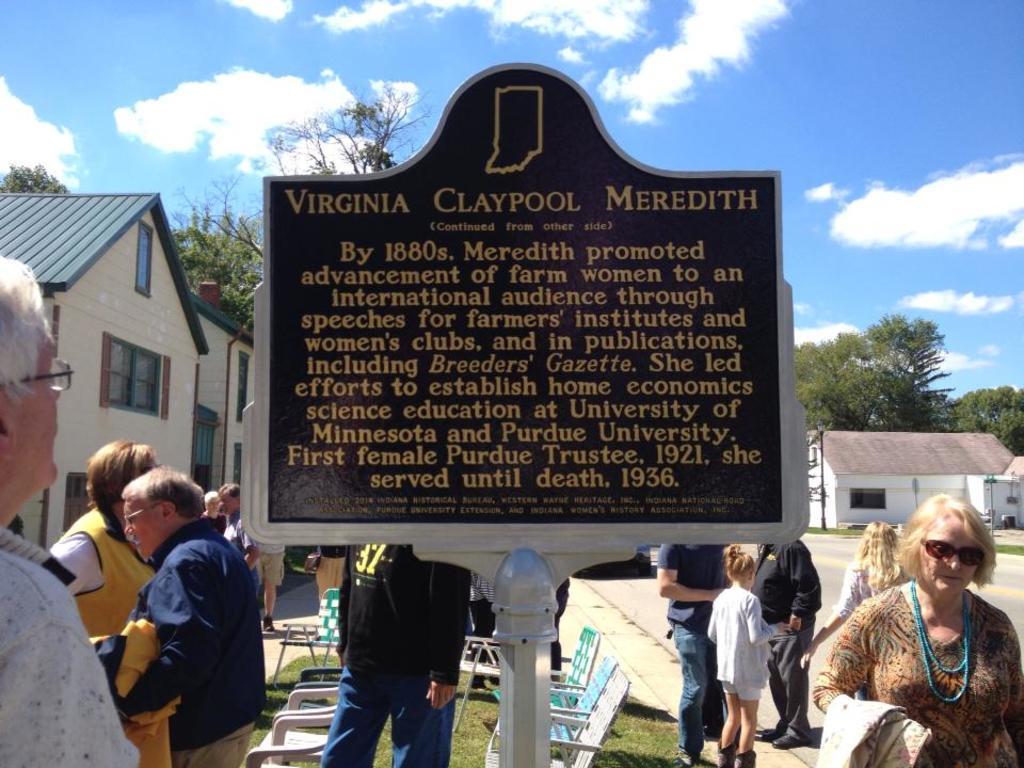How would you summarize this image in a sentence or two? In the center of the image we can see a board. On the board we can see the text. In the background of the image we can see the buildings, windows, trees, roofs and some people are standing. At the bottom of the image we can see the chairs, grass and the road. At the top of the image we can see the clouds in the sky. 